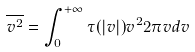<formula> <loc_0><loc_0><loc_500><loc_500>\overline { v ^ { 2 } } = \int _ { 0 } ^ { + \infty } \tau ( | { v } | ) v ^ { 2 } 2 \pi v d v</formula> 